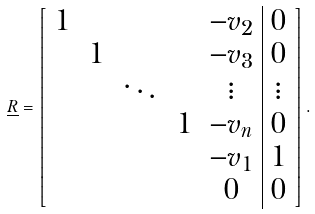Convert formula to latex. <formula><loc_0><loc_0><loc_500><loc_500>\underline { R } = \left [ \begin{array} { c c c c c | c } 1 & & & & - v _ { 2 } & 0 \\ & 1 & & & - v _ { 3 } & 0 \\ & & \ddots & & \vdots & \vdots \\ & & & 1 & - v _ { n } & 0 \\ & & & & - v _ { 1 } & 1 \\ & & & & 0 & 0 \end{array} \right ] .</formula> 